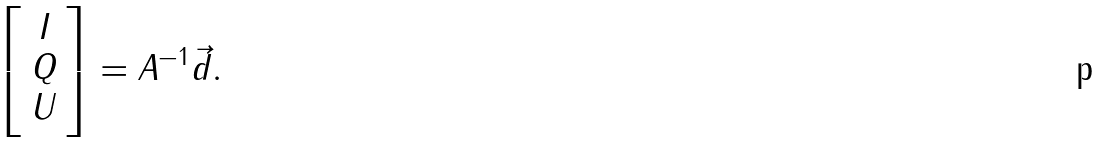<formula> <loc_0><loc_0><loc_500><loc_500>\left [ \begin{array} { c } I \\ Q \\ U \end{array} \right ] = A ^ { - 1 } \vec { d } .</formula> 